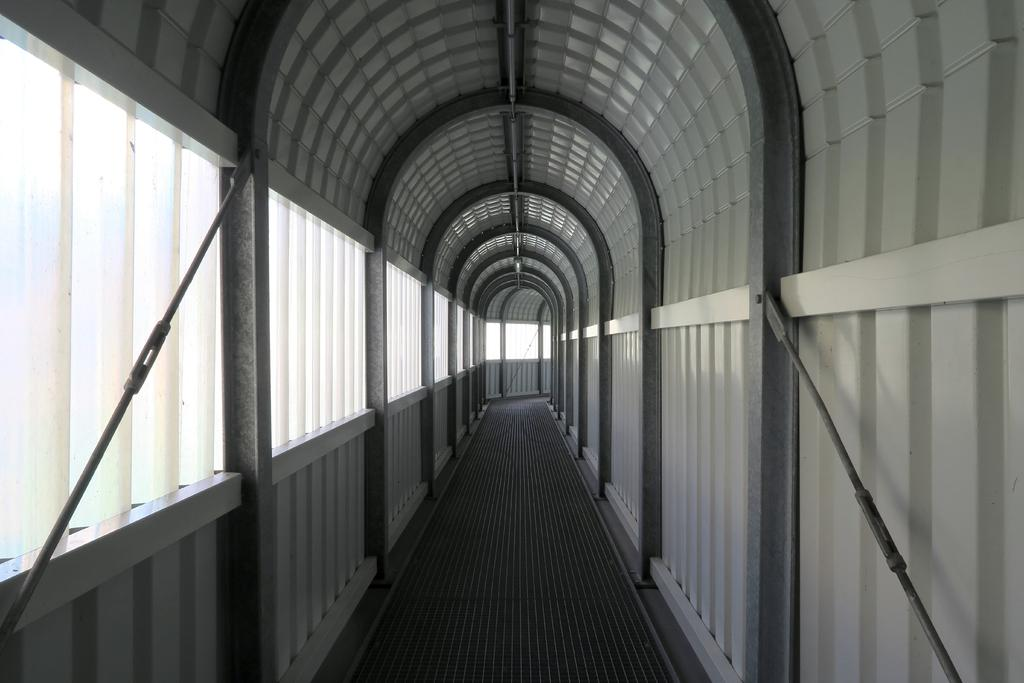What type of structure can be seen in the image? There is a wall in the image. What material is used for the rods in the image? Metal rods are present in the image. What part of the room is visible at the bottom of the image? The floor is visible at the bottom of the image. What part of the room is visible at the top of the image? The ceiling is visible at the top of the image. What type of chain can be seen on the top of the page in the image? There is no chain or page present in the image; it only features a wall, metal rods, the floor, and the ceiling. 